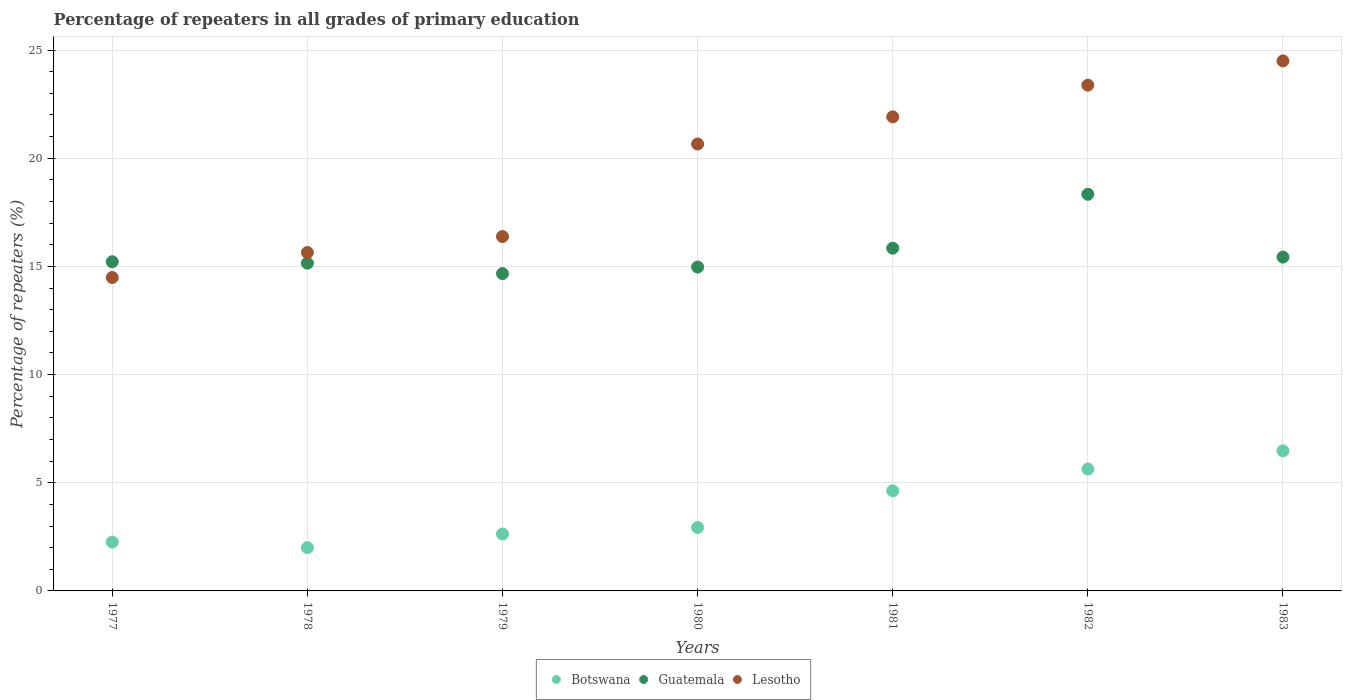How many different coloured dotlines are there?
Provide a succinct answer. 3. What is the percentage of repeaters in Botswana in 1980?
Your answer should be compact. 2.93. Across all years, what is the maximum percentage of repeaters in Lesotho?
Your answer should be compact. 24.5. Across all years, what is the minimum percentage of repeaters in Lesotho?
Ensure brevity in your answer.  14.49. In which year was the percentage of repeaters in Botswana minimum?
Keep it short and to the point. 1978. What is the total percentage of repeaters in Guatemala in the graph?
Keep it short and to the point. 109.61. What is the difference between the percentage of repeaters in Lesotho in 1978 and that in 1983?
Offer a terse response. -8.86. What is the difference between the percentage of repeaters in Guatemala in 1981 and the percentage of repeaters in Lesotho in 1980?
Keep it short and to the point. -4.82. What is the average percentage of repeaters in Lesotho per year?
Ensure brevity in your answer.  19.57. In the year 1981, what is the difference between the percentage of repeaters in Botswana and percentage of repeaters in Guatemala?
Make the answer very short. -11.21. In how many years, is the percentage of repeaters in Botswana greater than 7 %?
Make the answer very short. 0. What is the ratio of the percentage of repeaters in Lesotho in 1978 to that in 1982?
Provide a short and direct response. 0.67. Is the difference between the percentage of repeaters in Botswana in 1979 and 1982 greater than the difference between the percentage of repeaters in Guatemala in 1979 and 1982?
Your answer should be compact. Yes. What is the difference between the highest and the second highest percentage of repeaters in Botswana?
Make the answer very short. 0.84. What is the difference between the highest and the lowest percentage of repeaters in Guatemala?
Offer a terse response. 3.67. In how many years, is the percentage of repeaters in Guatemala greater than the average percentage of repeaters in Guatemala taken over all years?
Offer a very short reply. 2. Is it the case that in every year, the sum of the percentage of repeaters in Guatemala and percentage of repeaters in Lesotho  is greater than the percentage of repeaters in Botswana?
Provide a short and direct response. Yes. Does the percentage of repeaters in Guatemala monotonically increase over the years?
Provide a short and direct response. No. Is the percentage of repeaters in Lesotho strictly less than the percentage of repeaters in Botswana over the years?
Your response must be concise. No. How many dotlines are there?
Provide a short and direct response. 3. How many years are there in the graph?
Your response must be concise. 7. What is the difference between two consecutive major ticks on the Y-axis?
Provide a succinct answer. 5. Are the values on the major ticks of Y-axis written in scientific E-notation?
Offer a very short reply. No. Does the graph contain any zero values?
Your answer should be very brief. No. Does the graph contain grids?
Offer a terse response. Yes. Where does the legend appear in the graph?
Provide a succinct answer. Bottom center. How many legend labels are there?
Offer a very short reply. 3. What is the title of the graph?
Keep it short and to the point. Percentage of repeaters in all grades of primary education. Does "European Union" appear as one of the legend labels in the graph?
Your answer should be compact. No. What is the label or title of the X-axis?
Make the answer very short. Years. What is the label or title of the Y-axis?
Your answer should be very brief. Percentage of repeaters (%). What is the Percentage of repeaters (%) of Botswana in 1977?
Your answer should be very brief. 2.26. What is the Percentage of repeaters (%) in Guatemala in 1977?
Your response must be concise. 15.22. What is the Percentage of repeaters (%) in Lesotho in 1977?
Offer a very short reply. 14.49. What is the Percentage of repeaters (%) of Botswana in 1978?
Keep it short and to the point. 2. What is the Percentage of repeaters (%) in Guatemala in 1978?
Make the answer very short. 15.15. What is the Percentage of repeaters (%) in Lesotho in 1978?
Make the answer very short. 15.64. What is the Percentage of repeaters (%) of Botswana in 1979?
Provide a short and direct response. 2.63. What is the Percentage of repeaters (%) in Guatemala in 1979?
Your answer should be very brief. 14.67. What is the Percentage of repeaters (%) in Lesotho in 1979?
Your answer should be very brief. 16.38. What is the Percentage of repeaters (%) of Botswana in 1980?
Provide a short and direct response. 2.93. What is the Percentage of repeaters (%) in Guatemala in 1980?
Give a very brief answer. 14.97. What is the Percentage of repeaters (%) in Lesotho in 1980?
Offer a very short reply. 20.66. What is the Percentage of repeaters (%) in Botswana in 1981?
Provide a succinct answer. 4.63. What is the Percentage of repeaters (%) in Guatemala in 1981?
Your answer should be compact. 15.84. What is the Percentage of repeaters (%) in Lesotho in 1981?
Offer a very short reply. 21.92. What is the Percentage of repeaters (%) of Botswana in 1982?
Offer a terse response. 5.64. What is the Percentage of repeaters (%) of Guatemala in 1982?
Make the answer very short. 18.34. What is the Percentage of repeaters (%) of Lesotho in 1982?
Give a very brief answer. 23.38. What is the Percentage of repeaters (%) of Botswana in 1983?
Your response must be concise. 6.47. What is the Percentage of repeaters (%) of Guatemala in 1983?
Give a very brief answer. 15.43. What is the Percentage of repeaters (%) of Lesotho in 1983?
Provide a succinct answer. 24.5. Across all years, what is the maximum Percentage of repeaters (%) of Botswana?
Provide a succinct answer. 6.47. Across all years, what is the maximum Percentage of repeaters (%) in Guatemala?
Provide a succinct answer. 18.34. Across all years, what is the maximum Percentage of repeaters (%) in Lesotho?
Offer a very short reply. 24.5. Across all years, what is the minimum Percentage of repeaters (%) of Botswana?
Ensure brevity in your answer.  2. Across all years, what is the minimum Percentage of repeaters (%) of Guatemala?
Give a very brief answer. 14.67. Across all years, what is the minimum Percentage of repeaters (%) in Lesotho?
Your answer should be very brief. 14.49. What is the total Percentage of repeaters (%) in Botswana in the graph?
Offer a terse response. 26.56. What is the total Percentage of repeaters (%) of Guatemala in the graph?
Provide a succinct answer. 109.61. What is the total Percentage of repeaters (%) of Lesotho in the graph?
Offer a terse response. 136.96. What is the difference between the Percentage of repeaters (%) in Botswana in 1977 and that in 1978?
Ensure brevity in your answer.  0.26. What is the difference between the Percentage of repeaters (%) of Guatemala in 1977 and that in 1978?
Your answer should be compact. 0.07. What is the difference between the Percentage of repeaters (%) in Lesotho in 1977 and that in 1978?
Provide a short and direct response. -1.16. What is the difference between the Percentage of repeaters (%) in Botswana in 1977 and that in 1979?
Keep it short and to the point. -0.37. What is the difference between the Percentage of repeaters (%) in Guatemala in 1977 and that in 1979?
Provide a short and direct response. 0.55. What is the difference between the Percentage of repeaters (%) in Lesotho in 1977 and that in 1979?
Provide a succinct answer. -1.89. What is the difference between the Percentage of repeaters (%) in Botswana in 1977 and that in 1980?
Give a very brief answer. -0.67. What is the difference between the Percentage of repeaters (%) in Guatemala in 1977 and that in 1980?
Your response must be concise. 0.25. What is the difference between the Percentage of repeaters (%) in Lesotho in 1977 and that in 1980?
Your answer should be compact. -6.17. What is the difference between the Percentage of repeaters (%) of Botswana in 1977 and that in 1981?
Ensure brevity in your answer.  -2.37. What is the difference between the Percentage of repeaters (%) of Guatemala in 1977 and that in 1981?
Make the answer very short. -0.63. What is the difference between the Percentage of repeaters (%) of Lesotho in 1977 and that in 1981?
Provide a short and direct response. -7.43. What is the difference between the Percentage of repeaters (%) of Botswana in 1977 and that in 1982?
Give a very brief answer. -3.38. What is the difference between the Percentage of repeaters (%) in Guatemala in 1977 and that in 1982?
Give a very brief answer. -3.12. What is the difference between the Percentage of repeaters (%) of Lesotho in 1977 and that in 1982?
Make the answer very short. -8.89. What is the difference between the Percentage of repeaters (%) of Botswana in 1977 and that in 1983?
Keep it short and to the point. -4.22. What is the difference between the Percentage of repeaters (%) in Guatemala in 1977 and that in 1983?
Your answer should be very brief. -0.21. What is the difference between the Percentage of repeaters (%) in Lesotho in 1977 and that in 1983?
Offer a terse response. -10.01. What is the difference between the Percentage of repeaters (%) in Botswana in 1978 and that in 1979?
Make the answer very short. -0.63. What is the difference between the Percentage of repeaters (%) in Guatemala in 1978 and that in 1979?
Make the answer very short. 0.48. What is the difference between the Percentage of repeaters (%) of Lesotho in 1978 and that in 1979?
Make the answer very short. -0.74. What is the difference between the Percentage of repeaters (%) in Botswana in 1978 and that in 1980?
Ensure brevity in your answer.  -0.93. What is the difference between the Percentage of repeaters (%) of Guatemala in 1978 and that in 1980?
Your answer should be compact. 0.18. What is the difference between the Percentage of repeaters (%) in Lesotho in 1978 and that in 1980?
Provide a short and direct response. -5.02. What is the difference between the Percentage of repeaters (%) in Botswana in 1978 and that in 1981?
Keep it short and to the point. -2.63. What is the difference between the Percentage of repeaters (%) of Guatemala in 1978 and that in 1981?
Offer a terse response. -0.69. What is the difference between the Percentage of repeaters (%) of Lesotho in 1978 and that in 1981?
Your answer should be very brief. -6.27. What is the difference between the Percentage of repeaters (%) of Botswana in 1978 and that in 1982?
Provide a short and direct response. -3.64. What is the difference between the Percentage of repeaters (%) of Guatemala in 1978 and that in 1982?
Provide a succinct answer. -3.19. What is the difference between the Percentage of repeaters (%) of Lesotho in 1978 and that in 1982?
Offer a terse response. -7.74. What is the difference between the Percentage of repeaters (%) of Botswana in 1978 and that in 1983?
Your answer should be very brief. -4.47. What is the difference between the Percentage of repeaters (%) in Guatemala in 1978 and that in 1983?
Your response must be concise. -0.28. What is the difference between the Percentage of repeaters (%) in Lesotho in 1978 and that in 1983?
Give a very brief answer. -8.86. What is the difference between the Percentage of repeaters (%) of Botswana in 1979 and that in 1980?
Provide a short and direct response. -0.3. What is the difference between the Percentage of repeaters (%) of Guatemala in 1979 and that in 1980?
Offer a terse response. -0.3. What is the difference between the Percentage of repeaters (%) of Lesotho in 1979 and that in 1980?
Your response must be concise. -4.28. What is the difference between the Percentage of repeaters (%) of Botswana in 1979 and that in 1981?
Your answer should be compact. -2. What is the difference between the Percentage of repeaters (%) of Guatemala in 1979 and that in 1981?
Offer a very short reply. -1.18. What is the difference between the Percentage of repeaters (%) of Lesotho in 1979 and that in 1981?
Ensure brevity in your answer.  -5.53. What is the difference between the Percentage of repeaters (%) in Botswana in 1979 and that in 1982?
Offer a terse response. -3. What is the difference between the Percentage of repeaters (%) in Guatemala in 1979 and that in 1982?
Provide a succinct answer. -3.67. What is the difference between the Percentage of repeaters (%) of Lesotho in 1979 and that in 1982?
Keep it short and to the point. -7. What is the difference between the Percentage of repeaters (%) of Botswana in 1979 and that in 1983?
Keep it short and to the point. -3.84. What is the difference between the Percentage of repeaters (%) of Guatemala in 1979 and that in 1983?
Ensure brevity in your answer.  -0.76. What is the difference between the Percentage of repeaters (%) in Lesotho in 1979 and that in 1983?
Your answer should be very brief. -8.12. What is the difference between the Percentage of repeaters (%) of Botswana in 1980 and that in 1981?
Provide a short and direct response. -1.7. What is the difference between the Percentage of repeaters (%) in Guatemala in 1980 and that in 1981?
Make the answer very short. -0.87. What is the difference between the Percentage of repeaters (%) of Lesotho in 1980 and that in 1981?
Provide a succinct answer. -1.26. What is the difference between the Percentage of repeaters (%) of Botswana in 1980 and that in 1982?
Your answer should be very brief. -2.7. What is the difference between the Percentage of repeaters (%) in Guatemala in 1980 and that in 1982?
Your answer should be very brief. -3.36. What is the difference between the Percentage of repeaters (%) in Lesotho in 1980 and that in 1982?
Provide a short and direct response. -2.72. What is the difference between the Percentage of repeaters (%) in Botswana in 1980 and that in 1983?
Offer a terse response. -3.54. What is the difference between the Percentage of repeaters (%) in Guatemala in 1980 and that in 1983?
Give a very brief answer. -0.46. What is the difference between the Percentage of repeaters (%) of Lesotho in 1980 and that in 1983?
Your answer should be compact. -3.84. What is the difference between the Percentage of repeaters (%) in Botswana in 1981 and that in 1982?
Ensure brevity in your answer.  -1.01. What is the difference between the Percentage of repeaters (%) of Guatemala in 1981 and that in 1982?
Provide a short and direct response. -2.49. What is the difference between the Percentage of repeaters (%) in Lesotho in 1981 and that in 1982?
Provide a succinct answer. -1.46. What is the difference between the Percentage of repeaters (%) in Botswana in 1981 and that in 1983?
Provide a short and direct response. -1.85. What is the difference between the Percentage of repeaters (%) of Guatemala in 1981 and that in 1983?
Provide a succinct answer. 0.41. What is the difference between the Percentage of repeaters (%) in Lesotho in 1981 and that in 1983?
Your answer should be compact. -2.58. What is the difference between the Percentage of repeaters (%) in Botswana in 1982 and that in 1983?
Your response must be concise. -0.84. What is the difference between the Percentage of repeaters (%) in Guatemala in 1982 and that in 1983?
Offer a very short reply. 2.9. What is the difference between the Percentage of repeaters (%) of Lesotho in 1982 and that in 1983?
Your answer should be very brief. -1.12. What is the difference between the Percentage of repeaters (%) in Botswana in 1977 and the Percentage of repeaters (%) in Guatemala in 1978?
Your answer should be very brief. -12.89. What is the difference between the Percentage of repeaters (%) in Botswana in 1977 and the Percentage of repeaters (%) in Lesotho in 1978?
Offer a very short reply. -13.39. What is the difference between the Percentage of repeaters (%) of Guatemala in 1977 and the Percentage of repeaters (%) of Lesotho in 1978?
Ensure brevity in your answer.  -0.43. What is the difference between the Percentage of repeaters (%) of Botswana in 1977 and the Percentage of repeaters (%) of Guatemala in 1979?
Offer a very short reply. -12.41. What is the difference between the Percentage of repeaters (%) of Botswana in 1977 and the Percentage of repeaters (%) of Lesotho in 1979?
Your answer should be compact. -14.12. What is the difference between the Percentage of repeaters (%) of Guatemala in 1977 and the Percentage of repeaters (%) of Lesotho in 1979?
Provide a short and direct response. -1.16. What is the difference between the Percentage of repeaters (%) in Botswana in 1977 and the Percentage of repeaters (%) in Guatemala in 1980?
Your response must be concise. -12.71. What is the difference between the Percentage of repeaters (%) in Botswana in 1977 and the Percentage of repeaters (%) in Lesotho in 1980?
Offer a terse response. -18.4. What is the difference between the Percentage of repeaters (%) of Guatemala in 1977 and the Percentage of repeaters (%) of Lesotho in 1980?
Make the answer very short. -5.44. What is the difference between the Percentage of repeaters (%) in Botswana in 1977 and the Percentage of repeaters (%) in Guatemala in 1981?
Offer a very short reply. -13.58. What is the difference between the Percentage of repeaters (%) of Botswana in 1977 and the Percentage of repeaters (%) of Lesotho in 1981?
Your answer should be very brief. -19.66. What is the difference between the Percentage of repeaters (%) of Guatemala in 1977 and the Percentage of repeaters (%) of Lesotho in 1981?
Provide a short and direct response. -6.7. What is the difference between the Percentage of repeaters (%) in Botswana in 1977 and the Percentage of repeaters (%) in Guatemala in 1982?
Make the answer very short. -16.08. What is the difference between the Percentage of repeaters (%) in Botswana in 1977 and the Percentage of repeaters (%) in Lesotho in 1982?
Your answer should be very brief. -21.12. What is the difference between the Percentage of repeaters (%) of Guatemala in 1977 and the Percentage of repeaters (%) of Lesotho in 1982?
Provide a succinct answer. -8.16. What is the difference between the Percentage of repeaters (%) in Botswana in 1977 and the Percentage of repeaters (%) in Guatemala in 1983?
Make the answer very short. -13.17. What is the difference between the Percentage of repeaters (%) of Botswana in 1977 and the Percentage of repeaters (%) of Lesotho in 1983?
Offer a very short reply. -22.24. What is the difference between the Percentage of repeaters (%) in Guatemala in 1977 and the Percentage of repeaters (%) in Lesotho in 1983?
Ensure brevity in your answer.  -9.28. What is the difference between the Percentage of repeaters (%) in Botswana in 1978 and the Percentage of repeaters (%) in Guatemala in 1979?
Your answer should be very brief. -12.67. What is the difference between the Percentage of repeaters (%) of Botswana in 1978 and the Percentage of repeaters (%) of Lesotho in 1979?
Provide a succinct answer. -14.38. What is the difference between the Percentage of repeaters (%) in Guatemala in 1978 and the Percentage of repeaters (%) in Lesotho in 1979?
Your answer should be compact. -1.23. What is the difference between the Percentage of repeaters (%) in Botswana in 1978 and the Percentage of repeaters (%) in Guatemala in 1980?
Keep it short and to the point. -12.97. What is the difference between the Percentage of repeaters (%) in Botswana in 1978 and the Percentage of repeaters (%) in Lesotho in 1980?
Offer a very short reply. -18.66. What is the difference between the Percentage of repeaters (%) in Guatemala in 1978 and the Percentage of repeaters (%) in Lesotho in 1980?
Ensure brevity in your answer.  -5.51. What is the difference between the Percentage of repeaters (%) in Botswana in 1978 and the Percentage of repeaters (%) in Guatemala in 1981?
Give a very brief answer. -13.84. What is the difference between the Percentage of repeaters (%) of Botswana in 1978 and the Percentage of repeaters (%) of Lesotho in 1981?
Your answer should be compact. -19.92. What is the difference between the Percentage of repeaters (%) in Guatemala in 1978 and the Percentage of repeaters (%) in Lesotho in 1981?
Your response must be concise. -6.76. What is the difference between the Percentage of repeaters (%) in Botswana in 1978 and the Percentage of repeaters (%) in Guatemala in 1982?
Your answer should be compact. -16.34. What is the difference between the Percentage of repeaters (%) in Botswana in 1978 and the Percentage of repeaters (%) in Lesotho in 1982?
Ensure brevity in your answer.  -21.38. What is the difference between the Percentage of repeaters (%) of Guatemala in 1978 and the Percentage of repeaters (%) of Lesotho in 1982?
Give a very brief answer. -8.23. What is the difference between the Percentage of repeaters (%) in Botswana in 1978 and the Percentage of repeaters (%) in Guatemala in 1983?
Offer a very short reply. -13.43. What is the difference between the Percentage of repeaters (%) of Botswana in 1978 and the Percentage of repeaters (%) of Lesotho in 1983?
Your response must be concise. -22.5. What is the difference between the Percentage of repeaters (%) of Guatemala in 1978 and the Percentage of repeaters (%) of Lesotho in 1983?
Ensure brevity in your answer.  -9.35. What is the difference between the Percentage of repeaters (%) in Botswana in 1979 and the Percentage of repeaters (%) in Guatemala in 1980?
Your answer should be very brief. -12.34. What is the difference between the Percentage of repeaters (%) in Botswana in 1979 and the Percentage of repeaters (%) in Lesotho in 1980?
Your response must be concise. -18.03. What is the difference between the Percentage of repeaters (%) of Guatemala in 1979 and the Percentage of repeaters (%) of Lesotho in 1980?
Keep it short and to the point. -5.99. What is the difference between the Percentage of repeaters (%) of Botswana in 1979 and the Percentage of repeaters (%) of Guatemala in 1981?
Offer a very short reply. -13.21. What is the difference between the Percentage of repeaters (%) of Botswana in 1979 and the Percentage of repeaters (%) of Lesotho in 1981?
Your response must be concise. -19.28. What is the difference between the Percentage of repeaters (%) of Guatemala in 1979 and the Percentage of repeaters (%) of Lesotho in 1981?
Provide a short and direct response. -7.25. What is the difference between the Percentage of repeaters (%) of Botswana in 1979 and the Percentage of repeaters (%) of Guatemala in 1982?
Ensure brevity in your answer.  -15.71. What is the difference between the Percentage of repeaters (%) in Botswana in 1979 and the Percentage of repeaters (%) in Lesotho in 1982?
Provide a succinct answer. -20.75. What is the difference between the Percentage of repeaters (%) of Guatemala in 1979 and the Percentage of repeaters (%) of Lesotho in 1982?
Keep it short and to the point. -8.71. What is the difference between the Percentage of repeaters (%) of Botswana in 1979 and the Percentage of repeaters (%) of Guatemala in 1983?
Make the answer very short. -12.8. What is the difference between the Percentage of repeaters (%) in Botswana in 1979 and the Percentage of repeaters (%) in Lesotho in 1983?
Give a very brief answer. -21.87. What is the difference between the Percentage of repeaters (%) in Guatemala in 1979 and the Percentage of repeaters (%) in Lesotho in 1983?
Provide a succinct answer. -9.83. What is the difference between the Percentage of repeaters (%) of Botswana in 1980 and the Percentage of repeaters (%) of Guatemala in 1981?
Make the answer very short. -12.91. What is the difference between the Percentage of repeaters (%) of Botswana in 1980 and the Percentage of repeaters (%) of Lesotho in 1981?
Ensure brevity in your answer.  -18.98. What is the difference between the Percentage of repeaters (%) of Guatemala in 1980 and the Percentage of repeaters (%) of Lesotho in 1981?
Keep it short and to the point. -6.94. What is the difference between the Percentage of repeaters (%) of Botswana in 1980 and the Percentage of repeaters (%) of Guatemala in 1982?
Offer a terse response. -15.4. What is the difference between the Percentage of repeaters (%) of Botswana in 1980 and the Percentage of repeaters (%) of Lesotho in 1982?
Give a very brief answer. -20.45. What is the difference between the Percentage of repeaters (%) in Guatemala in 1980 and the Percentage of repeaters (%) in Lesotho in 1982?
Give a very brief answer. -8.41. What is the difference between the Percentage of repeaters (%) in Botswana in 1980 and the Percentage of repeaters (%) in Guatemala in 1983?
Provide a short and direct response. -12.5. What is the difference between the Percentage of repeaters (%) of Botswana in 1980 and the Percentage of repeaters (%) of Lesotho in 1983?
Give a very brief answer. -21.57. What is the difference between the Percentage of repeaters (%) in Guatemala in 1980 and the Percentage of repeaters (%) in Lesotho in 1983?
Ensure brevity in your answer.  -9.53. What is the difference between the Percentage of repeaters (%) in Botswana in 1981 and the Percentage of repeaters (%) in Guatemala in 1982?
Ensure brevity in your answer.  -13.71. What is the difference between the Percentage of repeaters (%) of Botswana in 1981 and the Percentage of repeaters (%) of Lesotho in 1982?
Provide a succinct answer. -18.75. What is the difference between the Percentage of repeaters (%) in Guatemala in 1981 and the Percentage of repeaters (%) in Lesotho in 1982?
Provide a succinct answer. -7.54. What is the difference between the Percentage of repeaters (%) in Botswana in 1981 and the Percentage of repeaters (%) in Guatemala in 1983?
Provide a succinct answer. -10.8. What is the difference between the Percentage of repeaters (%) in Botswana in 1981 and the Percentage of repeaters (%) in Lesotho in 1983?
Provide a short and direct response. -19.87. What is the difference between the Percentage of repeaters (%) in Guatemala in 1981 and the Percentage of repeaters (%) in Lesotho in 1983?
Your response must be concise. -8.66. What is the difference between the Percentage of repeaters (%) in Botswana in 1982 and the Percentage of repeaters (%) in Guatemala in 1983?
Your answer should be compact. -9.8. What is the difference between the Percentage of repeaters (%) in Botswana in 1982 and the Percentage of repeaters (%) in Lesotho in 1983?
Your answer should be compact. -18.86. What is the difference between the Percentage of repeaters (%) in Guatemala in 1982 and the Percentage of repeaters (%) in Lesotho in 1983?
Provide a short and direct response. -6.16. What is the average Percentage of repeaters (%) in Botswana per year?
Offer a very short reply. 3.79. What is the average Percentage of repeaters (%) in Guatemala per year?
Offer a very short reply. 15.66. What is the average Percentage of repeaters (%) of Lesotho per year?
Ensure brevity in your answer.  19.57. In the year 1977, what is the difference between the Percentage of repeaters (%) in Botswana and Percentage of repeaters (%) in Guatemala?
Offer a terse response. -12.96. In the year 1977, what is the difference between the Percentage of repeaters (%) of Botswana and Percentage of repeaters (%) of Lesotho?
Ensure brevity in your answer.  -12.23. In the year 1977, what is the difference between the Percentage of repeaters (%) of Guatemala and Percentage of repeaters (%) of Lesotho?
Keep it short and to the point. 0.73. In the year 1978, what is the difference between the Percentage of repeaters (%) in Botswana and Percentage of repeaters (%) in Guatemala?
Give a very brief answer. -13.15. In the year 1978, what is the difference between the Percentage of repeaters (%) in Botswana and Percentage of repeaters (%) in Lesotho?
Give a very brief answer. -13.64. In the year 1978, what is the difference between the Percentage of repeaters (%) of Guatemala and Percentage of repeaters (%) of Lesotho?
Your answer should be compact. -0.49. In the year 1979, what is the difference between the Percentage of repeaters (%) in Botswana and Percentage of repeaters (%) in Guatemala?
Make the answer very short. -12.04. In the year 1979, what is the difference between the Percentage of repeaters (%) in Botswana and Percentage of repeaters (%) in Lesotho?
Keep it short and to the point. -13.75. In the year 1979, what is the difference between the Percentage of repeaters (%) of Guatemala and Percentage of repeaters (%) of Lesotho?
Provide a succinct answer. -1.71. In the year 1980, what is the difference between the Percentage of repeaters (%) in Botswana and Percentage of repeaters (%) in Guatemala?
Keep it short and to the point. -12.04. In the year 1980, what is the difference between the Percentage of repeaters (%) in Botswana and Percentage of repeaters (%) in Lesotho?
Give a very brief answer. -17.73. In the year 1980, what is the difference between the Percentage of repeaters (%) in Guatemala and Percentage of repeaters (%) in Lesotho?
Make the answer very short. -5.69. In the year 1981, what is the difference between the Percentage of repeaters (%) in Botswana and Percentage of repeaters (%) in Guatemala?
Your answer should be very brief. -11.21. In the year 1981, what is the difference between the Percentage of repeaters (%) in Botswana and Percentage of repeaters (%) in Lesotho?
Keep it short and to the point. -17.29. In the year 1981, what is the difference between the Percentage of repeaters (%) in Guatemala and Percentage of repeaters (%) in Lesotho?
Provide a short and direct response. -6.07. In the year 1982, what is the difference between the Percentage of repeaters (%) of Botswana and Percentage of repeaters (%) of Guatemala?
Offer a terse response. -12.7. In the year 1982, what is the difference between the Percentage of repeaters (%) of Botswana and Percentage of repeaters (%) of Lesotho?
Your answer should be very brief. -17.74. In the year 1982, what is the difference between the Percentage of repeaters (%) in Guatemala and Percentage of repeaters (%) in Lesotho?
Provide a short and direct response. -5.04. In the year 1983, what is the difference between the Percentage of repeaters (%) of Botswana and Percentage of repeaters (%) of Guatemala?
Your response must be concise. -8.96. In the year 1983, what is the difference between the Percentage of repeaters (%) in Botswana and Percentage of repeaters (%) in Lesotho?
Ensure brevity in your answer.  -18.02. In the year 1983, what is the difference between the Percentage of repeaters (%) of Guatemala and Percentage of repeaters (%) of Lesotho?
Provide a succinct answer. -9.07. What is the ratio of the Percentage of repeaters (%) of Botswana in 1977 to that in 1978?
Your answer should be compact. 1.13. What is the ratio of the Percentage of repeaters (%) of Guatemala in 1977 to that in 1978?
Make the answer very short. 1. What is the ratio of the Percentage of repeaters (%) in Lesotho in 1977 to that in 1978?
Keep it short and to the point. 0.93. What is the ratio of the Percentage of repeaters (%) in Botswana in 1977 to that in 1979?
Give a very brief answer. 0.86. What is the ratio of the Percentage of repeaters (%) of Guatemala in 1977 to that in 1979?
Your answer should be very brief. 1.04. What is the ratio of the Percentage of repeaters (%) in Lesotho in 1977 to that in 1979?
Offer a very short reply. 0.88. What is the ratio of the Percentage of repeaters (%) in Botswana in 1977 to that in 1980?
Your response must be concise. 0.77. What is the ratio of the Percentage of repeaters (%) of Guatemala in 1977 to that in 1980?
Ensure brevity in your answer.  1.02. What is the ratio of the Percentage of repeaters (%) in Lesotho in 1977 to that in 1980?
Offer a terse response. 0.7. What is the ratio of the Percentage of repeaters (%) of Botswana in 1977 to that in 1981?
Keep it short and to the point. 0.49. What is the ratio of the Percentage of repeaters (%) in Guatemala in 1977 to that in 1981?
Give a very brief answer. 0.96. What is the ratio of the Percentage of repeaters (%) in Lesotho in 1977 to that in 1981?
Your answer should be very brief. 0.66. What is the ratio of the Percentage of repeaters (%) in Botswana in 1977 to that in 1982?
Offer a terse response. 0.4. What is the ratio of the Percentage of repeaters (%) of Guatemala in 1977 to that in 1982?
Keep it short and to the point. 0.83. What is the ratio of the Percentage of repeaters (%) of Lesotho in 1977 to that in 1982?
Offer a very short reply. 0.62. What is the ratio of the Percentage of repeaters (%) of Botswana in 1977 to that in 1983?
Make the answer very short. 0.35. What is the ratio of the Percentage of repeaters (%) in Guatemala in 1977 to that in 1983?
Your response must be concise. 0.99. What is the ratio of the Percentage of repeaters (%) in Lesotho in 1977 to that in 1983?
Your answer should be compact. 0.59. What is the ratio of the Percentage of repeaters (%) of Botswana in 1978 to that in 1979?
Your answer should be very brief. 0.76. What is the ratio of the Percentage of repeaters (%) of Guatemala in 1978 to that in 1979?
Provide a short and direct response. 1.03. What is the ratio of the Percentage of repeaters (%) in Lesotho in 1978 to that in 1979?
Your answer should be compact. 0.95. What is the ratio of the Percentage of repeaters (%) in Botswana in 1978 to that in 1980?
Your answer should be compact. 0.68. What is the ratio of the Percentage of repeaters (%) in Lesotho in 1978 to that in 1980?
Offer a very short reply. 0.76. What is the ratio of the Percentage of repeaters (%) in Botswana in 1978 to that in 1981?
Your response must be concise. 0.43. What is the ratio of the Percentage of repeaters (%) of Guatemala in 1978 to that in 1981?
Your response must be concise. 0.96. What is the ratio of the Percentage of repeaters (%) of Lesotho in 1978 to that in 1981?
Your answer should be very brief. 0.71. What is the ratio of the Percentage of repeaters (%) in Botswana in 1978 to that in 1982?
Make the answer very short. 0.35. What is the ratio of the Percentage of repeaters (%) in Guatemala in 1978 to that in 1982?
Provide a short and direct response. 0.83. What is the ratio of the Percentage of repeaters (%) of Lesotho in 1978 to that in 1982?
Ensure brevity in your answer.  0.67. What is the ratio of the Percentage of repeaters (%) in Botswana in 1978 to that in 1983?
Offer a very short reply. 0.31. What is the ratio of the Percentage of repeaters (%) of Guatemala in 1978 to that in 1983?
Make the answer very short. 0.98. What is the ratio of the Percentage of repeaters (%) of Lesotho in 1978 to that in 1983?
Offer a terse response. 0.64. What is the ratio of the Percentage of repeaters (%) of Botswana in 1979 to that in 1980?
Keep it short and to the point. 0.9. What is the ratio of the Percentage of repeaters (%) in Guatemala in 1979 to that in 1980?
Your answer should be very brief. 0.98. What is the ratio of the Percentage of repeaters (%) in Lesotho in 1979 to that in 1980?
Offer a very short reply. 0.79. What is the ratio of the Percentage of repeaters (%) of Botswana in 1979 to that in 1981?
Your answer should be compact. 0.57. What is the ratio of the Percentage of repeaters (%) of Guatemala in 1979 to that in 1981?
Make the answer very short. 0.93. What is the ratio of the Percentage of repeaters (%) of Lesotho in 1979 to that in 1981?
Offer a terse response. 0.75. What is the ratio of the Percentage of repeaters (%) in Botswana in 1979 to that in 1982?
Offer a terse response. 0.47. What is the ratio of the Percentage of repeaters (%) in Guatemala in 1979 to that in 1982?
Offer a terse response. 0.8. What is the ratio of the Percentage of repeaters (%) of Lesotho in 1979 to that in 1982?
Ensure brevity in your answer.  0.7. What is the ratio of the Percentage of repeaters (%) in Botswana in 1979 to that in 1983?
Your answer should be very brief. 0.41. What is the ratio of the Percentage of repeaters (%) of Guatemala in 1979 to that in 1983?
Offer a terse response. 0.95. What is the ratio of the Percentage of repeaters (%) in Lesotho in 1979 to that in 1983?
Your answer should be very brief. 0.67. What is the ratio of the Percentage of repeaters (%) in Botswana in 1980 to that in 1981?
Your answer should be compact. 0.63. What is the ratio of the Percentage of repeaters (%) of Guatemala in 1980 to that in 1981?
Keep it short and to the point. 0.94. What is the ratio of the Percentage of repeaters (%) of Lesotho in 1980 to that in 1981?
Your response must be concise. 0.94. What is the ratio of the Percentage of repeaters (%) of Botswana in 1980 to that in 1982?
Your response must be concise. 0.52. What is the ratio of the Percentage of repeaters (%) of Guatemala in 1980 to that in 1982?
Keep it short and to the point. 0.82. What is the ratio of the Percentage of repeaters (%) in Lesotho in 1980 to that in 1982?
Your answer should be very brief. 0.88. What is the ratio of the Percentage of repeaters (%) of Botswana in 1980 to that in 1983?
Offer a very short reply. 0.45. What is the ratio of the Percentage of repeaters (%) of Guatemala in 1980 to that in 1983?
Provide a succinct answer. 0.97. What is the ratio of the Percentage of repeaters (%) in Lesotho in 1980 to that in 1983?
Keep it short and to the point. 0.84. What is the ratio of the Percentage of repeaters (%) of Botswana in 1981 to that in 1982?
Offer a terse response. 0.82. What is the ratio of the Percentage of repeaters (%) in Guatemala in 1981 to that in 1982?
Make the answer very short. 0.86. What is the ratio of the Percentage of repeaters (%) of Lesotho in 1981 to that in 1982?
Make the answer very short. 0.94. What is the ratio of the Percentage of repeaters (%) in Botswana in 1981 to that in 1983?
Your answer should be compact. 0.71. What is the ratio of the Percentage of repeaters (%) of Guatemala in 1981 to that in 1983?
Make the answer very short. 1.03. What is the ratio of the Percentage of repeaters (%) of Lesotho in 1981 to that in 1983?
Make the answer very short. 0.89. What is the ratio of the Percentage of repeaters (%) of Botswana in 1982 to that in 1983?
Provide a succinct answer. 0.87. What is the ratio of the Percentage of repeaters (%) in Guatemala in 1982 to that in 1983?
Your answer should be compact. 1.19. What is the ratio of the Percentage of repeaters (%) in Lesotho in 1982 to that in 1983?
Your answer should be compact. 0.95. What is the difference between the highest and the second highest Percentage of repeaters (%) of Botswana?
Your answer should be compact. 0.84. What is the difference between the highest and the second highest Percentage of repeaters (%) in Guatemala?
Your answer should be compact. 2.49. What is the difference between the highest and the second highest Percentage of repeaters (%) of Lesotho?
Keep it short and to the point. 1.12. What is the difference between the highest and the lowest Percentage of repeaters (%) in Botswana?
Offer a very short reply. 4.47. What is the difference between the highest and the lowest Percentage of repeaters (%) in Guatemala?
Ensure brevity in your answer.  3.67. What is the difference between the highest and the lowest Percentage of repeaters (%) in Lesotho?
Ensure brevity in your answer.  10.01. 